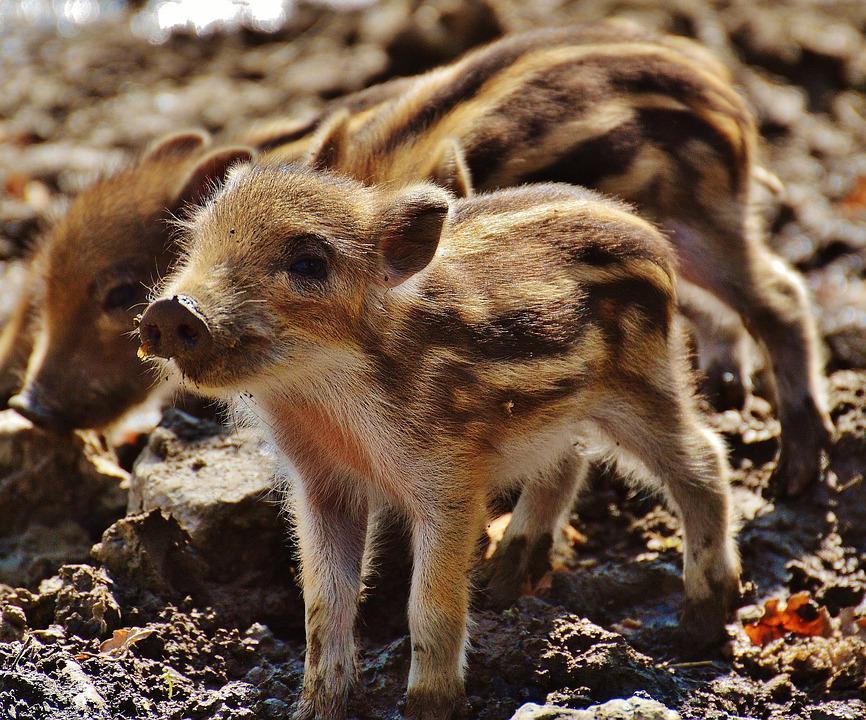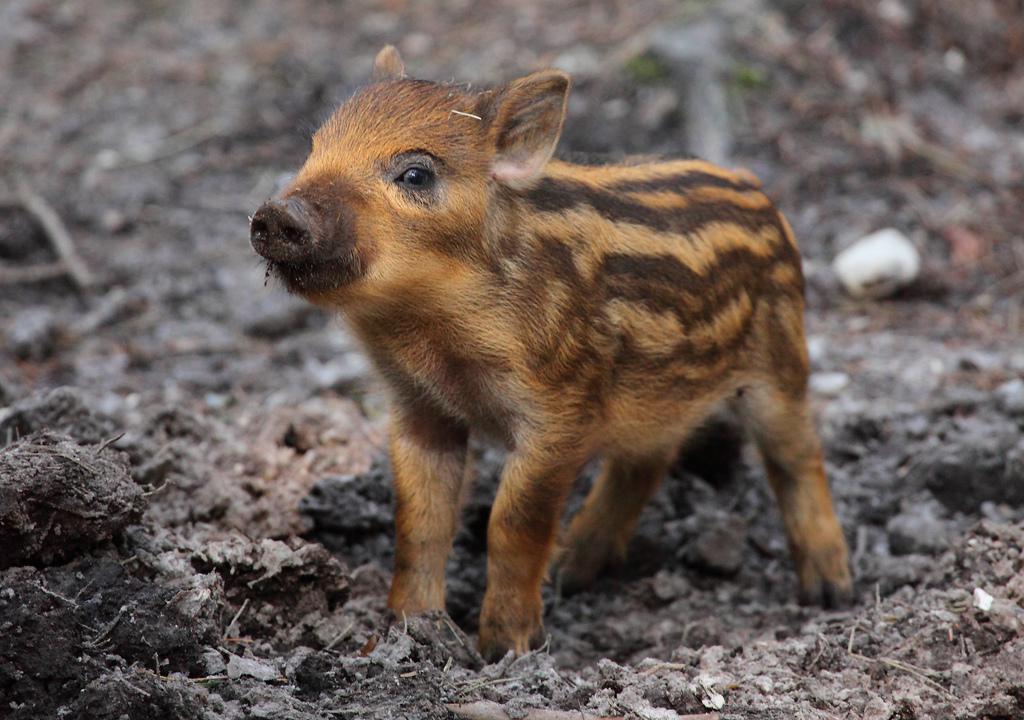The first image is the image on the left, the second image is the image on the right. For the images displayed, is the sentence "There are more pigs in the right image than in the left image." factually correct? Answer yes or no. No. The first image is the image on the left, the second image is the image on the right. Examine the images to the left and right. Is the description "There are at most three boar piglets." accurate? Answer yes or no. Yes. 